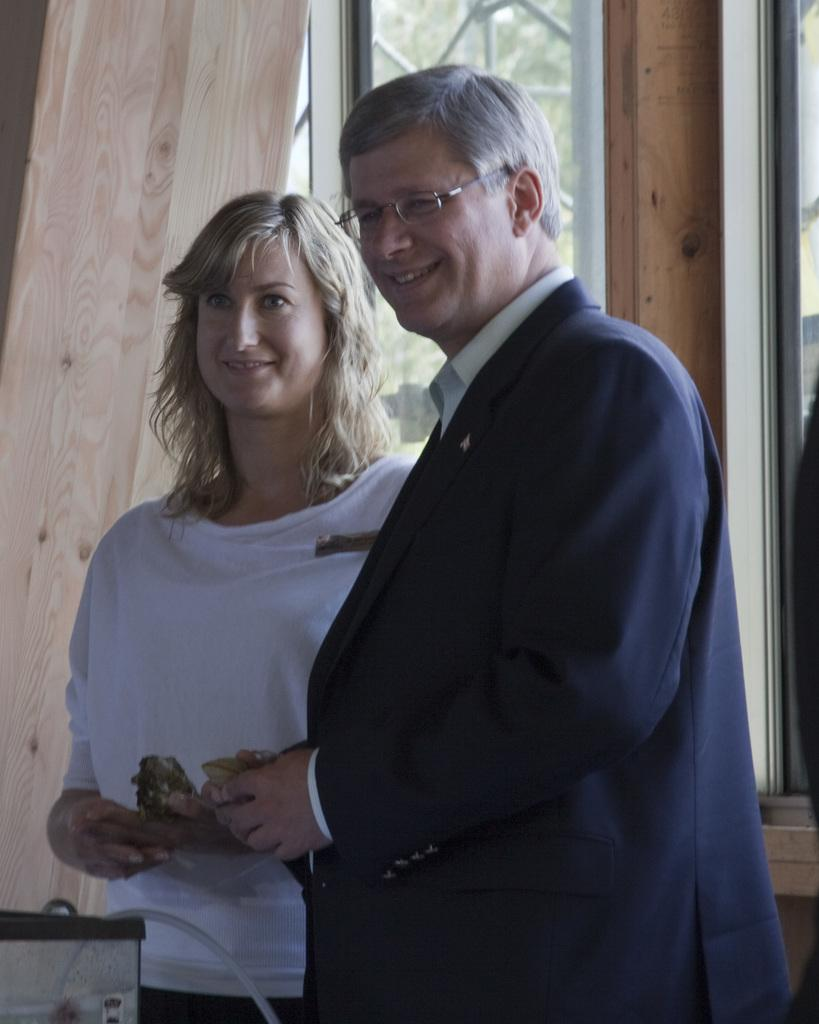How many people are in the image? There are two people in the image. What are the people doing in the image? The people are standing and smiling. What can be seen in the background of the image? There are windows, trees, a wooden plank, and some objects in the background of the image. What is the maid writing on the wax in the image? There is no maid, writing, or wax present in the image. 